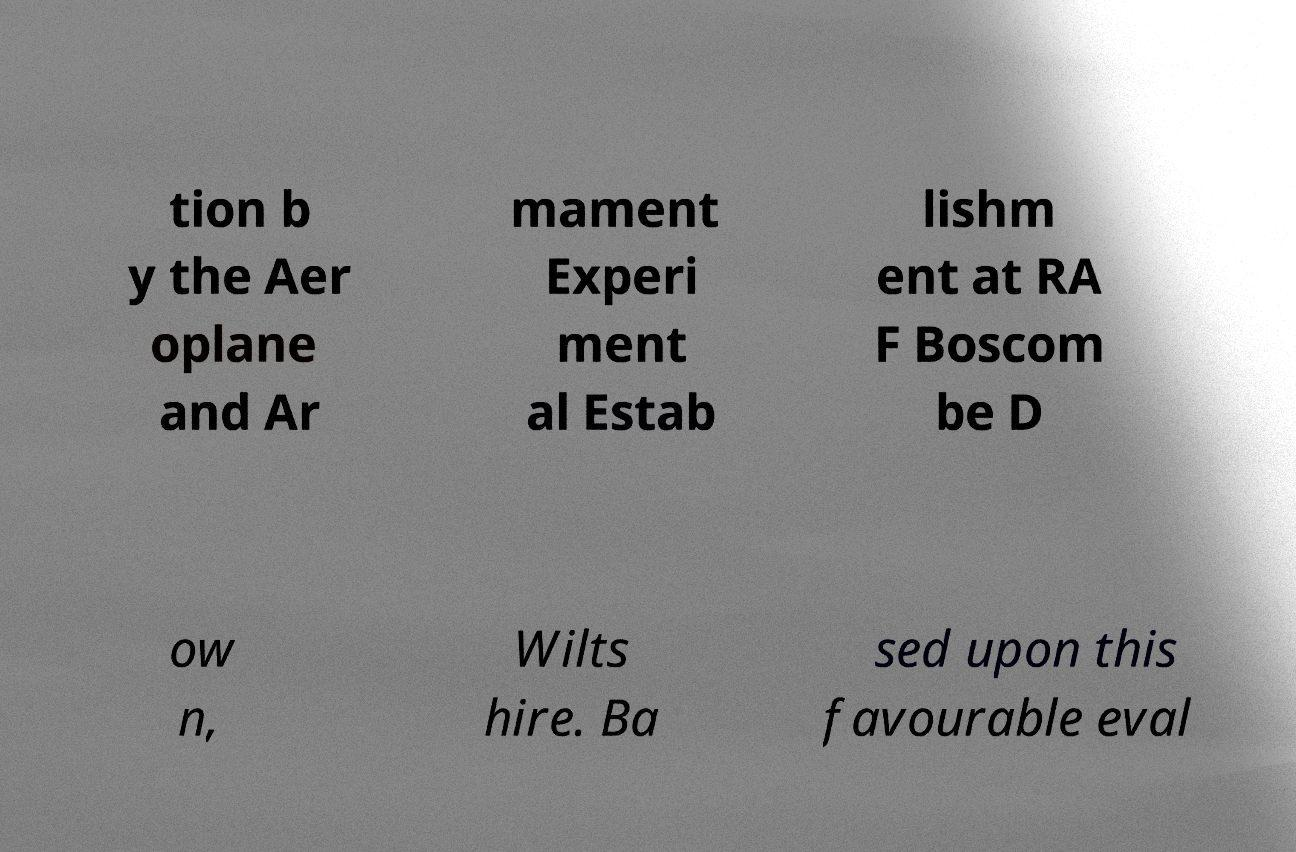There's text embedded in this image that I need extracted. Can you transcribe it verbatim? tion b y the Aer oplane and Ar mament Experi ment al Estab lishm ent at RA F Boscom be D ow n, Wilts hire. Ba sed upon this favourable eval 